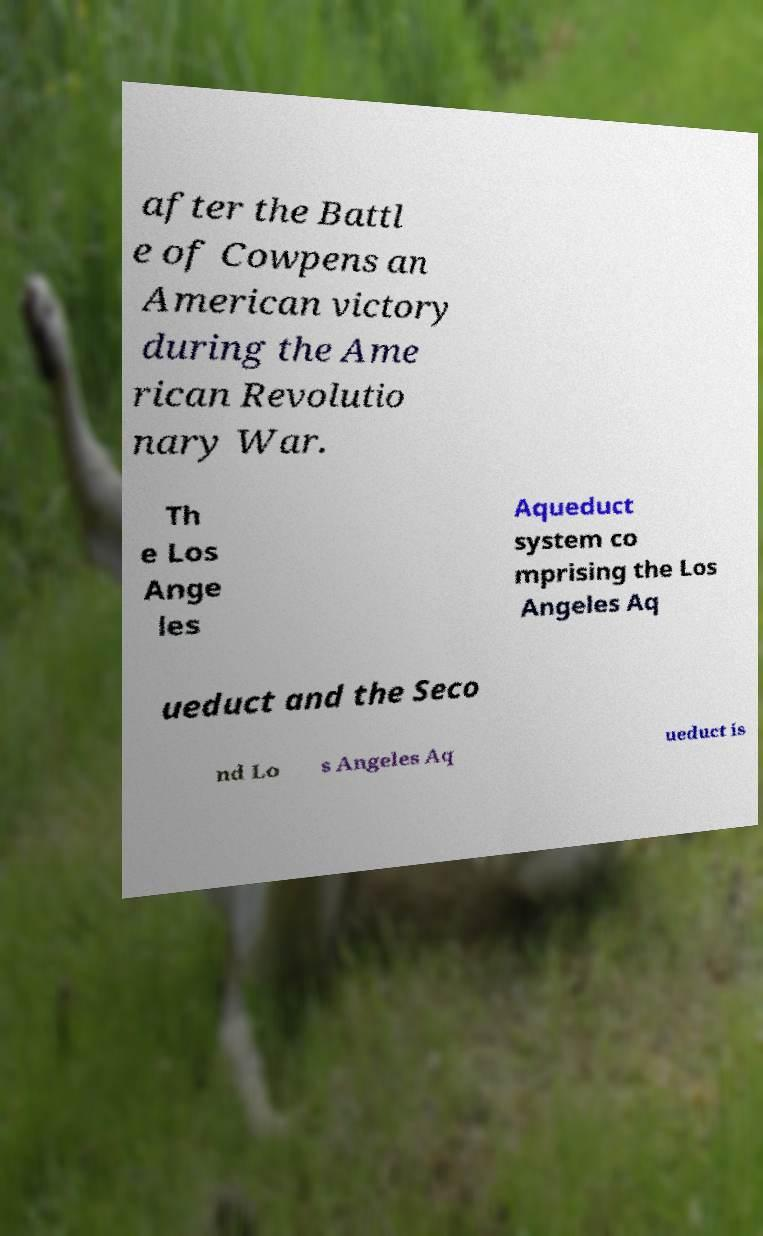I need the written content from this picture converted into text. Can you do that? after the Battl e of Cowpens an American victory during the Ame rican Revolutio nary War. Th e Los Ange les Aqueduct system co mprising the Los Angeles Aq ueduct and the Seco nd Lo s Angeles Aq ueduct is 